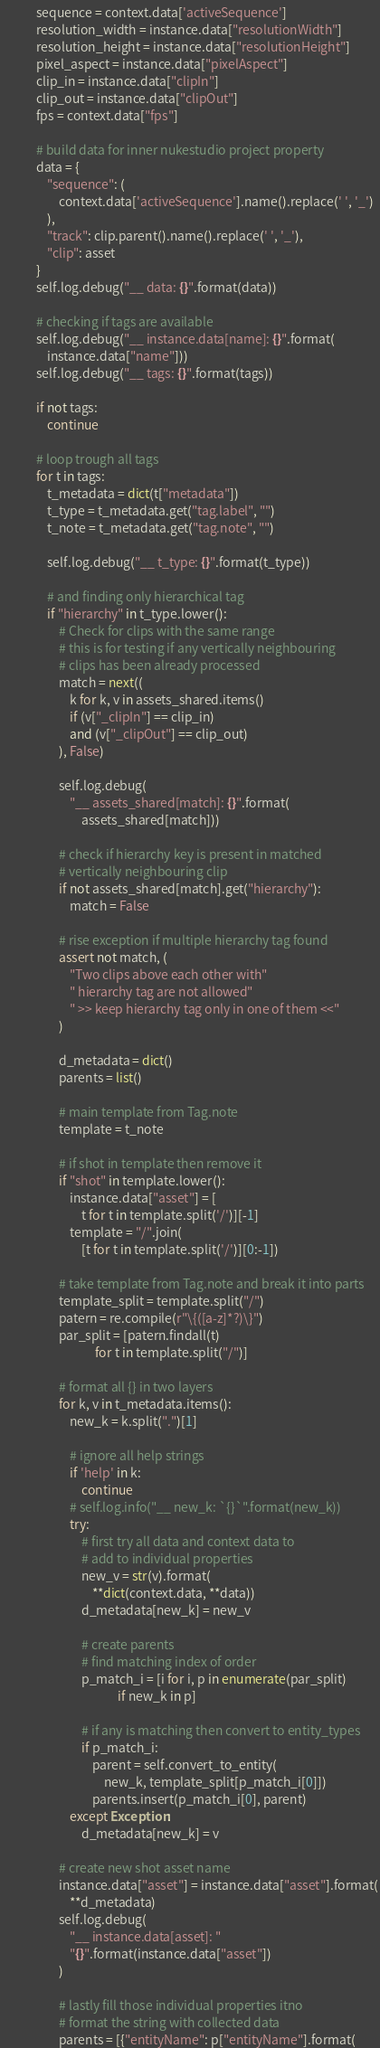<code> <loc_0><loc_0><loc_500><loc_500><_Python_>            sequence = context.data['activeSequence']
            resolution_width = instance.data["resolutionWidth"]
            resolution_height = instance.data["resolutionHeight"]
            pixel_aspect = instance.data["pixelAspect"]
            clip_in = instance.data["clipIn"]
            clip_out = instance.data["clipOut"]
            fps = context.data["fps"]

            # build data for inner nukestudio project property
            data = {
                "sequence": (
                    context.data['activeSequence'].name().replace(' ', '_')
                ),
                "track": clip.parent().name().replace(' ', '_'),
                "clip": asset
            }
            self.log.debug("__ data: {}".format(data))

            # checking if tags are available
            self.log.debug("__ instance.data[name]: {}".format(
                instance.data["name"]))
            self.log.debug("__ tags: {}".format(tags))

            if not tags:
                continue

            # loop trough all tags
            for t in tags:
                t_metadata = dict(t["metadata"])
                t_type = t_metadata.get("tag.label", "")
                t_note = t_metadata.get("tag.note", "")

                self.log.debug("__ t_type: {}".format(t_type))

                # and finding only hierarchical tag
                if "hierarchy" in t_type.lower():
                    # Check for clips with the same range
                    # this is for testing if any vertically neighbouring
                    # clips has been already processed
                    match = next((
                        k for k, v in assets_shared.items()
                        if (v["_clipIn"] == clip_in)
                        and (v["_clipOut"] == clip_out)
                    ), False)

                    self.log.debug(
                        "__ assets_shared[match]: {}".format(
                            assets_shared[match]))

                    # check if hierarchy key is present in matched
                    # vertically neighbouring clip
                    if not assets_shared[match].get("hierarchy"):
                        match = False

                    # rise exception if multiple hierarchy tag found
                    assert not match, (
                        "Two clips above each other with"
                        " hierarchy tag are not allowed"
                        " >> keep hierarchy tag only in one of them <<"
                    )

                    d_metadata = dict()
                    parents = list()

                    # main template from Tag.note
                    template = t_note

                    # if shot in template then remove it
                    if "shot" in template.lower():
                        instance.data["asset"] = [
                            t for t in template.split('/')][-1]
                        template = "/".join(
                            [t for t in template.split('/')][0:-1])

                    # take template from Tag.note and break it into parts
                    template_split = template.split("/")
                    patern = re.compile(r"\{([a-z]*?)\}")
                    par_split = [patern.findall(t)
                                 for t in template.split("/")]

                    # format all {} in two layers
                    for k, v in t_metadata.items():
                        new_k = k.split(".")[1]

                        # ignore all help strings
                        if 'help' in k:
                            continue
                        # self.log.info("__ new_k: `{}`".format(new_k))
                        try:
                            # first try all data and context data to
                            # add to individual properties
                            new_v = str(v).format(
                                **dict(context.data, **data))
                            d_metadata[new_k] = new_v

                            # create parents
                            # find matching index of order
                            p_match_i = [i for i, p in enumerate(par_split)
                                         if new_k in p]

                            # if any is matching then convert to entity_types
                            if p_match_i:
                                parent = self.convert_to_entity(
                                    new_k, template_split[p_match_i[0]])
                                parents.insert(p_match_i[0], parent)
                        except Exception:
                            d_metadata[new_k] = v

                    # create new shot asset name
                    instance.data["asset"] = instance.data["asset"].format(
                        **d_metadata)
                    self.log.debug(
                        "__ instance.data[asset]: "
                        "{}".format(instance.data["asset"])
                    )

                    # lastly fill those individual properties itno
                    # format the string with collected data
                    parents = [{"entityName": p["entityName"].format(</code> 